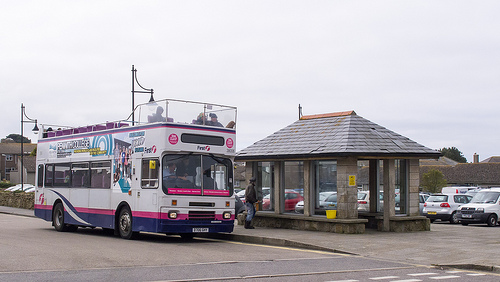What vehicle is driving? The bus is driving. 